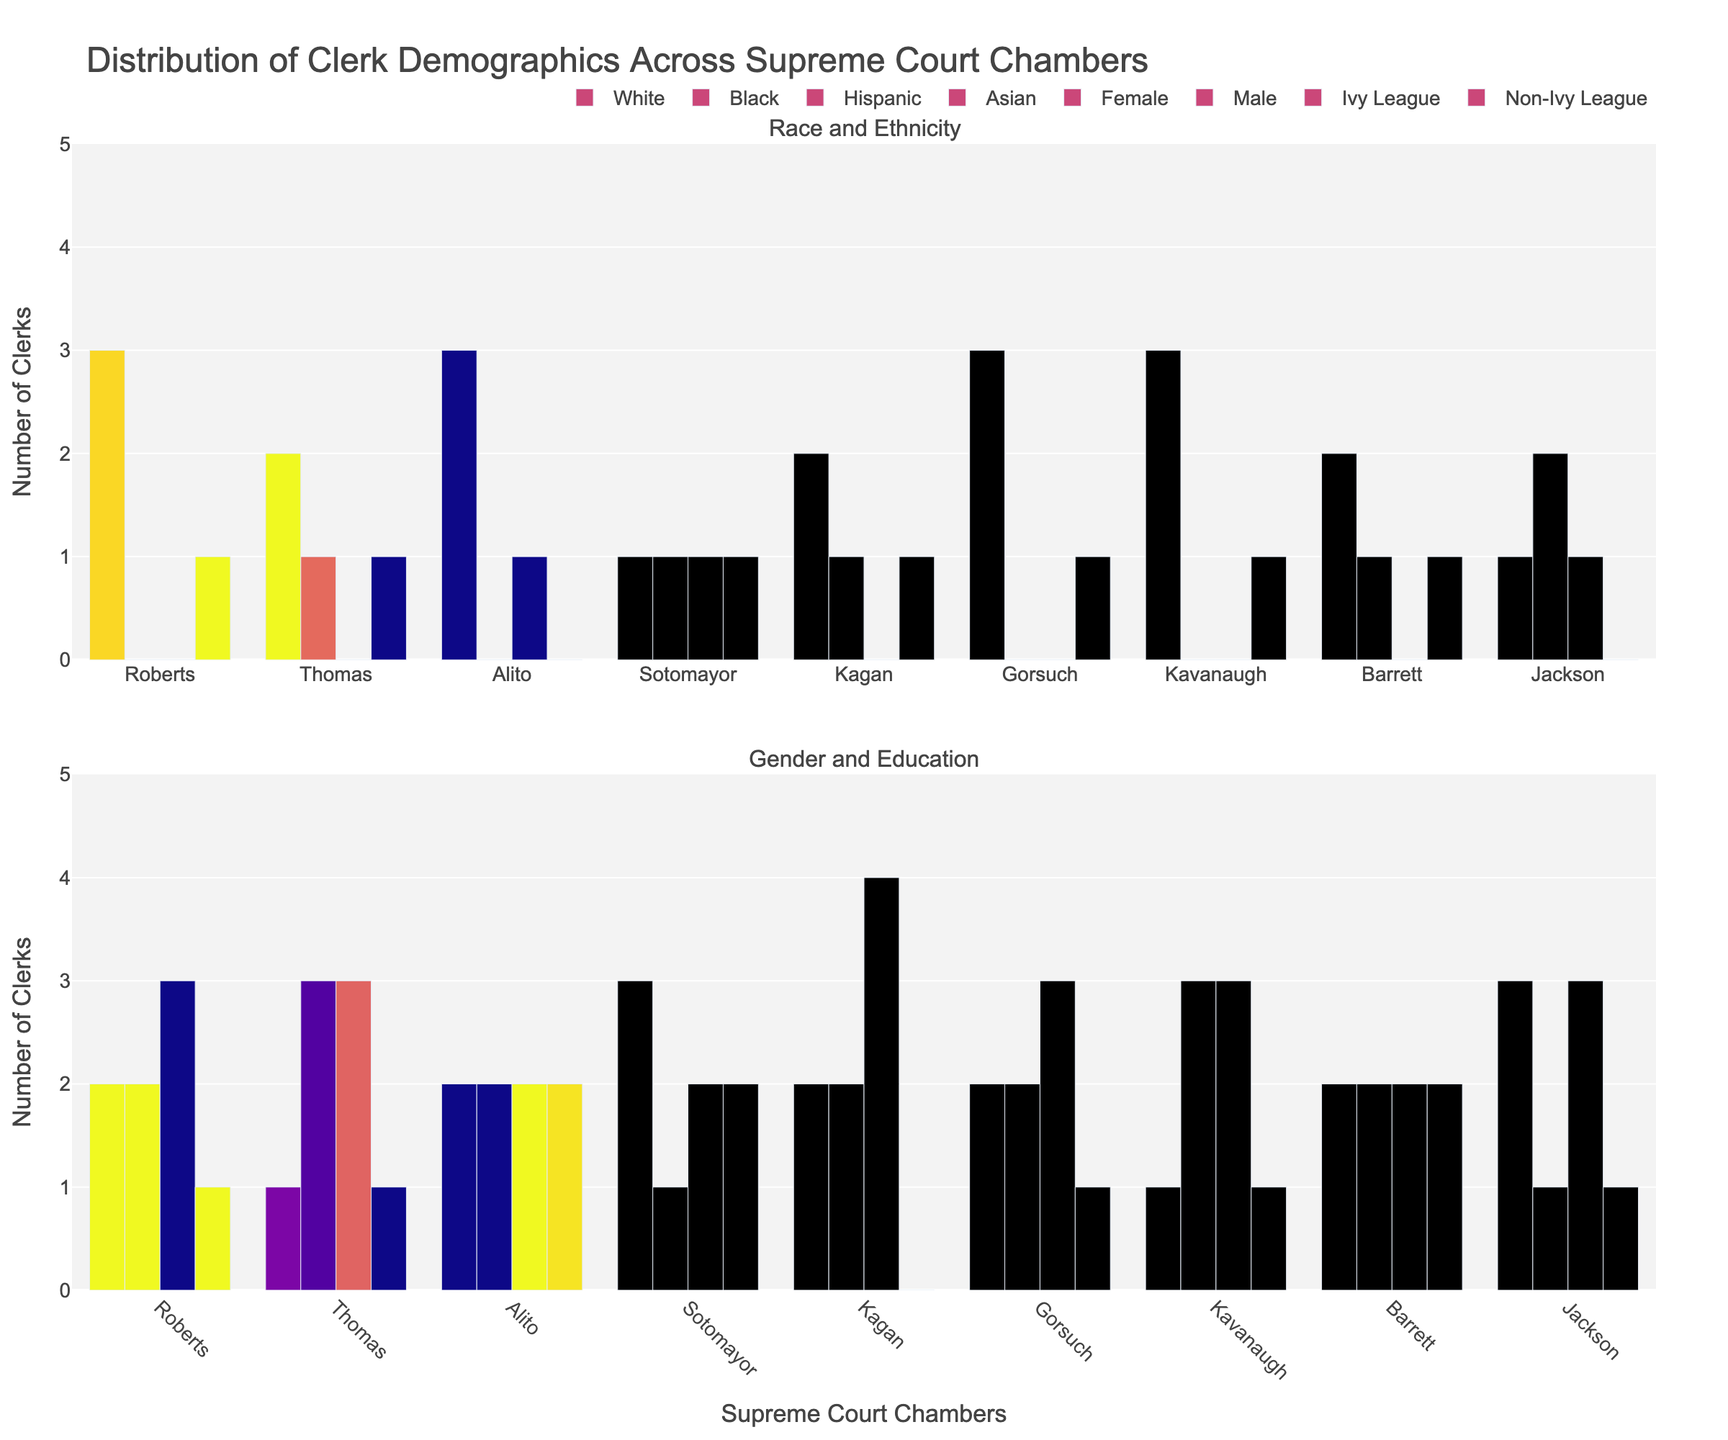Which chamber has the highest number of clerks overall? By adding the counts of all demographic categories (White, Black, Hispanic, Asian, Female, Male, Ivy League, Non-Ivy League) for each chamber, Roberts, Gorsuch, and Kavanaugh each have a total of 8 clerks, which is the highest.
Answer: Roberts, Gorsuch, Kavanaugh Who has more female clerks, Sotomayor or Alito? Sotomayor has 3 female clerks while Alito has 2 female clerks, so Sotomayor has more.
Answer: Sotomayor What's the average number of Ivy League clerks per chamber? Summing Ivy League clerks for all chambers gives: 3 (Roberts) + 3 (Thomas) + 2 (Alito) + 2 (Sotomayor) + 4 (Kagan) + 3 (Gorsuch) + 3 (Kavanaugh) + 2 (Barrett) + 3 (Jackson) = 25. There are 9 chambers. 25 / 9 ≈ 2.78
Answer: 2.78 Which chamber has the most diverse race/ethnicity composition? Sotomayor and Jackson each have clerks from all four categories (White, Black, Hispanic, Asian), making them the most diverse chambers in terms of race/ethnicity.
Answer: Sotomayor, Jackson How many chambers have equal numbers of male and female clerks? Roberts and Alito each have 2 male and 2 female clerks, so there are 2 chambers with equal numbers of male and female clerks.
Answer: 2 Which chambers have no Black clerks? By examining the Black category, Roberts, Gorsuch, Alito, and Kavanaugh chambers have 0 Black clerks.
Answer: Roberts, Gorsuch, Alito, Kavanaugh In which chamber do Hispanic clerks outnumber Black and Asian clerks? In Alito's chamber, Hispanic clerks (1) outnumber both Black (0) and Asian (0) clerks.
Answer: Alito What's the difference between the number of male clerks in Thomas's chamber and Kavanaugh's chamber? Thomas has 3 male clerks, and Kavanaugh has 3 male clerks. The difference is 3 - 3 = 0.
Answer: 0 How many chambers have exactly 1 Asian clerk? Roberts, Thomas, Sotomayor, Kagan, Gorsuch, Kavanaugh, and Barrett chambers each have 1 Asian clerk. So, 7 chambers have exactly 1 Asian clerk.
Answer: 7 